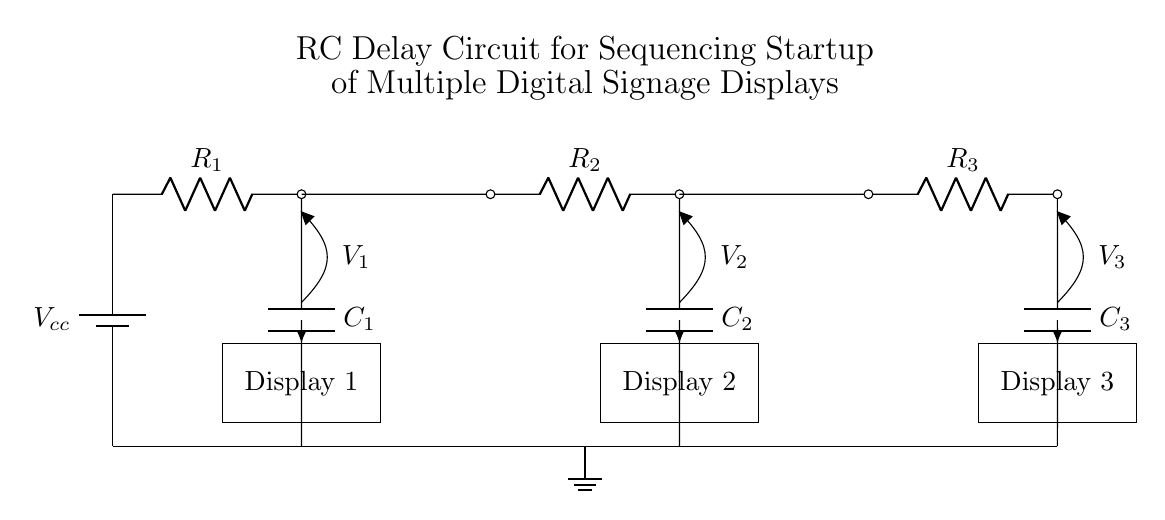What is the total number of displays in the circuit? The circuit diagram clearly shows three individual displays labeled as Display 1, Display 2, and Display 3. Therefore, the total number of displays in this circuit is three.
Answer: three What is the function of the capacitors in this RC delay circuit? In an RC delay circuit, capacitors store electrical energy and release it gradually. Their charging and discharging process determines the time delay for the activation of each display sequentially.
Answer: store energy What are the resistance values present in this circuit? The circuit lists three resistors: R1, R2, and R3. However, the specific numerical values aren’t provided in the diagram, only their labels. Each resistor is represented equally without numeric values.
Answer: R1, R2, R3 Which component controls the delay between the display startups? Capacitors are crucial in controlling the delay; their charging time when connected with resistors determines when the voltages for the displays are activated. The combination of resistor and capacitor values dictates the delay.
Answer: capacitors What happens if only one capacitor is added to the circuit? Adding just one capacitor would limit the delay functionality to only one display, preventing the sequenced startup of multiple displays. It would result in only the connected display powering on after the delay defined by that single capacitor.
Answer: limited delay What is the role of the voltage labeled V1? V1 is the output voltage across the first capacitor and resistor combination, determining when Display 1 is activated. The level of V1 corresponds to the time necessary for C1 to charge through R1 to reach a specific threshold.
Answer: output voltage What type of circuit configuration is used in this design? The circuit configuration is an RC delay circuit, which is specifically designed to sequence the startup of connected displays through resistors and capacitors. The series connection of these elements creates the intended delay effect.
Answer: RC delay circuit 